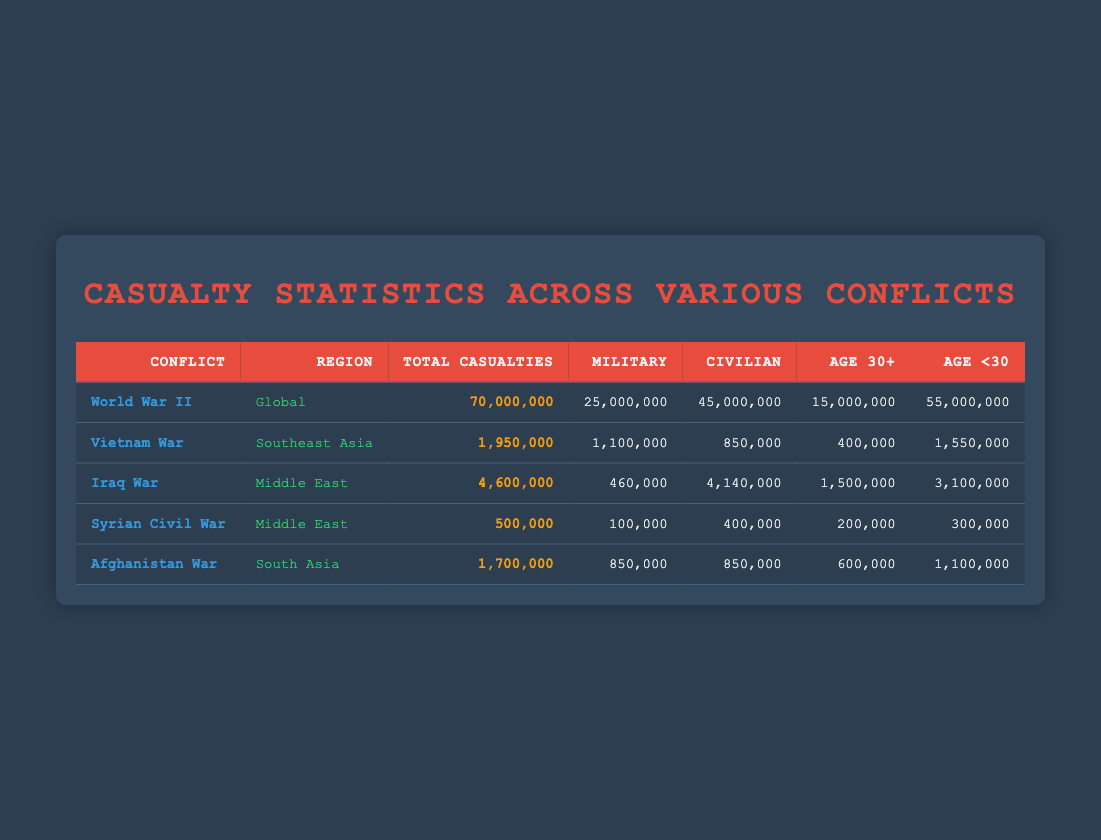What is the total number of casualties in World War II? The total casualties in World War II is listed directly in the table under the "Total Casualties" column. It shows a value of 70,000,000.
Answer: 70,000,000 How many military casualties were there in the Iraq War? The number of military casualties in the Iraq War is found in the relevant row under the "Military" column. It indicates a value of 460,000.
Answer: 460,000 What is the combined number of military and civilian casualties in the Vietnam War? To find the combined casualties, I add the military and civilian casualties from the Vietnam War. Therefore, 1,100,000 (military) + 850,000 (civilian) = 1,950,000.
Answer: 1,950,000 Which conflict had the highest number of civilian casualties, and what was that number? Looking through the table, the Iraq War has the highest civilian casualties at 4,140,000, compared to other conflicts.
Answer: Iraq War; 4,140,000 Is the total number of casualties higher in the Afghan War than in the Vietnam War? The total casualties for the Afghan War is 1,700,000 and for the Vietnam War is 1,950,000. Therefore, the Afghan War has fewer casualties.
Answer: No What percentage of total casualties in the Syrian Civil War are military casualties? The Syrian Civil War has 500,000 total casualties and 100,000 military casualties. To find the percentage, I calculate (100,000 / 500,000) * 100 = 20%.
Answer: 20% How many more casualties were there in World War II compared to the Afghanistan War? World War II has 70,000,000 total casualties and the Afghanistan War has 1,700,000. To find the difference, I subtract: 70,000,000 - 1,700,000 = 68,300,000.
Answer: 68,300,000 What is the average number of casualties for the conflicts listed in the table? To find the average, I sum all total casualties (70,000,000 + 1,950,000 + 4,600,000 + 500,000 + 1,700,000 = 78,750,000) and divide by the number of conflicts (5), yielding an average of 15,750,000.
Answer: 15,750,000 Did the total casualties in the Iraq War exceed those in the Syrian Civil War? The total casualties in the Iraq War amount to 4,600,000, while the Syrian Civil War has 500,000 total casualties. Since 4,600,000 is greater than 500,000, the Iraq War's total casualties do indeed exceed those of the Syrian War.
Answer: Yes 